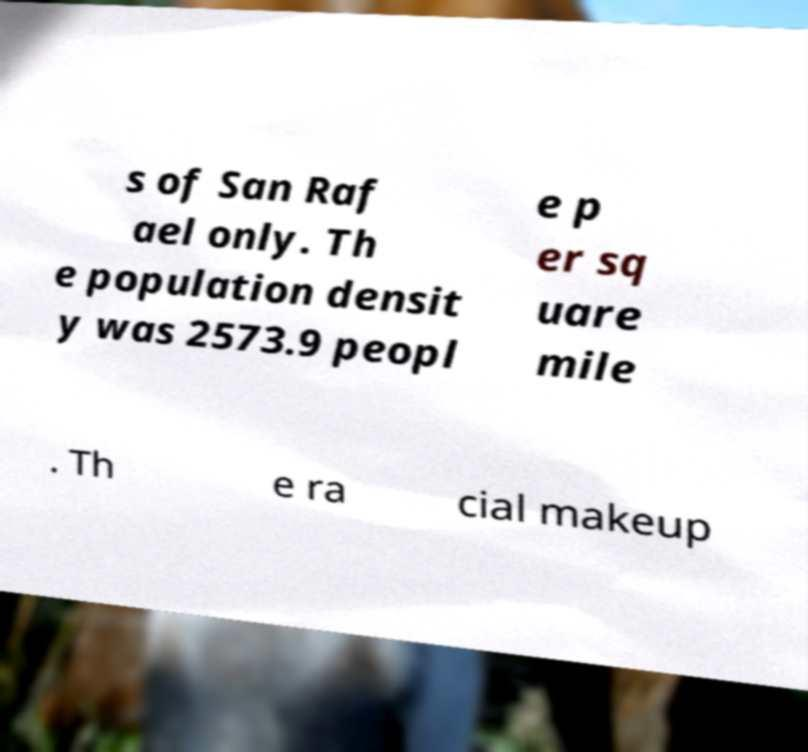What messages or text are displayed in this image? I need them in a readable, typed format. s of San Raf ael only. Th e population densit y was 2573.9 peopl e p er sq uare mile . Th e ra cial makeup 